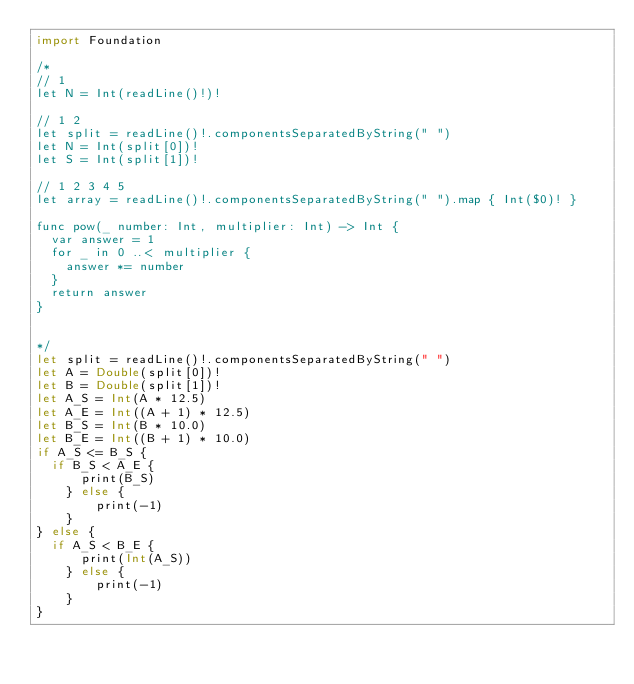Convert code to text. <code><loc_0><loc_0><loc_500><loc_500><_Swift_>import Foundation

/*
// 1
let N = Int(readLine()!)!

// 1 2
let split = readLine()!.componentsSeparatedByString(" ")
let N = Int(split[0])!
let S = Int(split[1])!

// 1 2 3 4 5
let array = readLine()!.componentsSeparatedByString(" ").map { Int($0)! }

func pow(_ number: Int, multiplier: Int) -> Int {
  var answer = 1
  for _ in 0 ..< multiplier {
    answer *= number 
  }
  return answer
}


*/
let split = readLine()!.componentsSeparatedByString(" ")
let A = Double(split[0])!
let B = Double(split[1])!
let A_S = Int(A * 12.5)
let A_E = Int((A + 1) * 12.5)
let B_S = Int(B * 10.0)
let B_E = Int((B + 1) * 10.0)
if A_S <= B_S {
	if B_S < A_E {
    	print(B_S)
    } else {
        print(-1)
    }
} else {
	if A_S < B_E {
    	print(Int(A_S))
    } else {
        print(-1)
    }
}</code> 